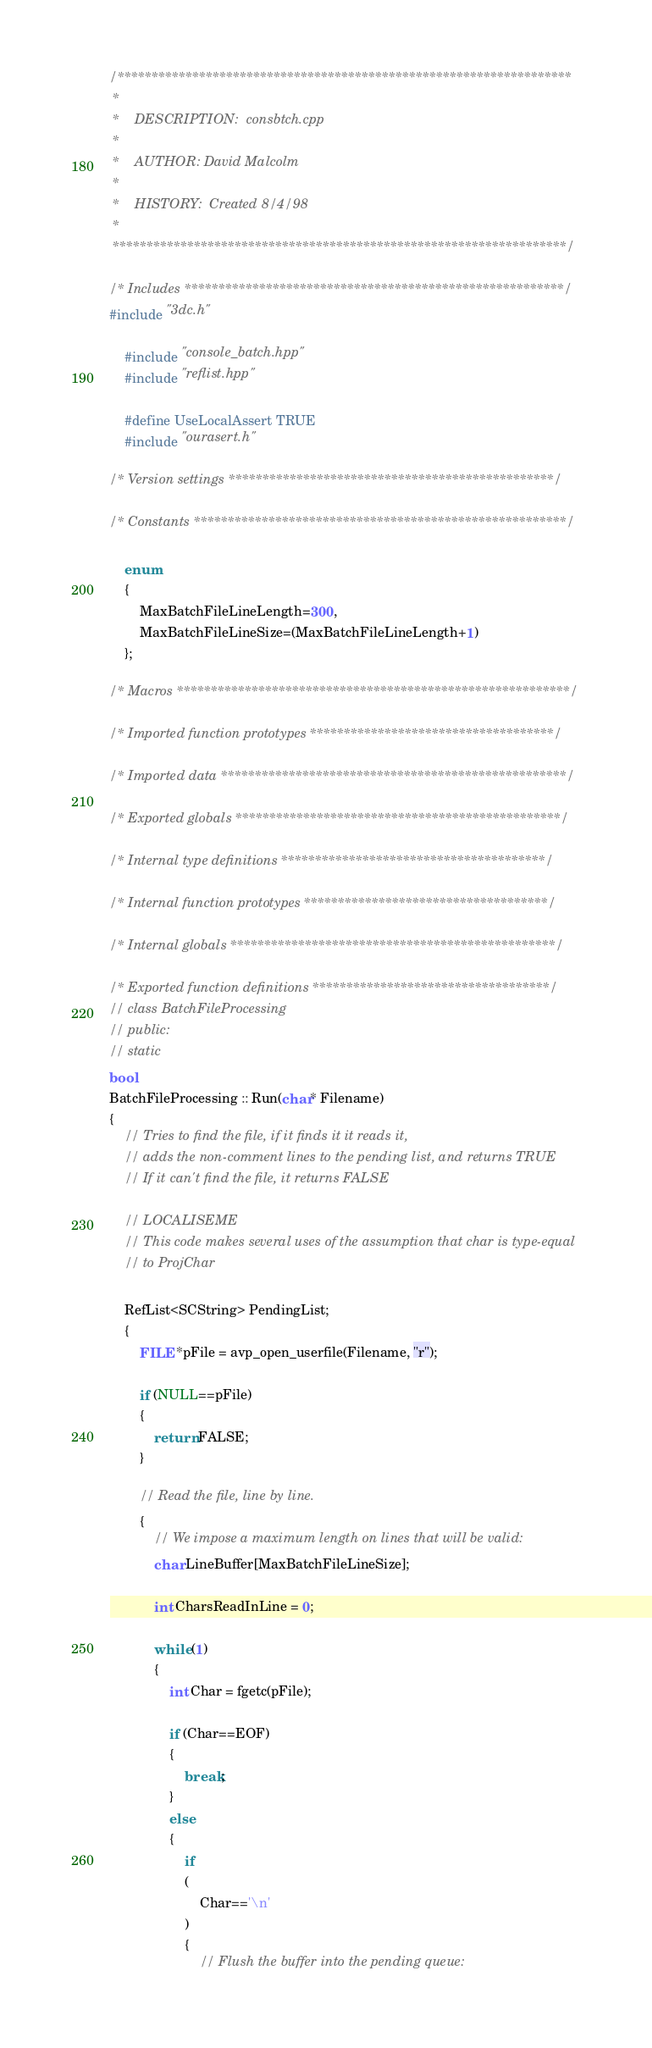<code> <loc_0><loc_0><loc_500><loc_500><_C++_>/*******************************************************************
 *
 *    DESCRIPTION: 	consbtch.cpp
 *
 *    AUTHOR: David Malcolm
 *
 *    HISTORY:  Created 8/4/98
 *
 *******************************************************************/

/* Includes ********************************************************/
#include "3dc.h"

	#include "console_batch.hpp"
	#include "reflist.hpp"

	#define UseLocalAssert TRUE
	#include "ourasert.h"

/* Version settings ************************************************/

/* Constants *******************************************************/

	enum
	{
		MaxBatchFileLineLength=300,
		MaxBatchFileLineSize=(MaxBatchFileLineLength+1)
	};

/* Macros **********************************************************/

/* Imported function prototypes ************************************/

/* Imported data ***************************************************/

/* Exported globals ************************************************/

/* Internal type definitions ***************************************/

/* Internal function prototypes ************************************/

/* Internal globals ************************************************/

/* Exported function definitions ***********************************/
// class BatchFileProcessing
// public:
// static
bool
BatchFileProcessing :: Run(char* Filename)
{
	// Tries to find the file, if it finds it it reads it,
	// adds the non-comment lines to the pending list, and returns TRUE
	// If it can't find the file, it returns FALSE

	// LOCALISEME
	// This code makes several uses of the assumption that char is type-equal
	// to ProjChar

	RefList<SCString> PendingList;
	{
		FILE *pFile = avp_open_userfile(Filename, "r");

		if (NULL==pFile)
		{
			return FALSE;
		}

		// Read the file, line by line.  
		{
			// We impose a maximum length on lines that will be valid:
			char LineBuffer[MaxBatchFileLineSize];

			int CharsReadInLine = 0;

			while (1)
			{
				int Char = fgetc(pFile);

				if (Char==EOF)
				{
					break;
				}
				else
				{
					if
					(
						Char=='\n'
					)
					{
						// Flush the buffer into the pending queue:</code> 